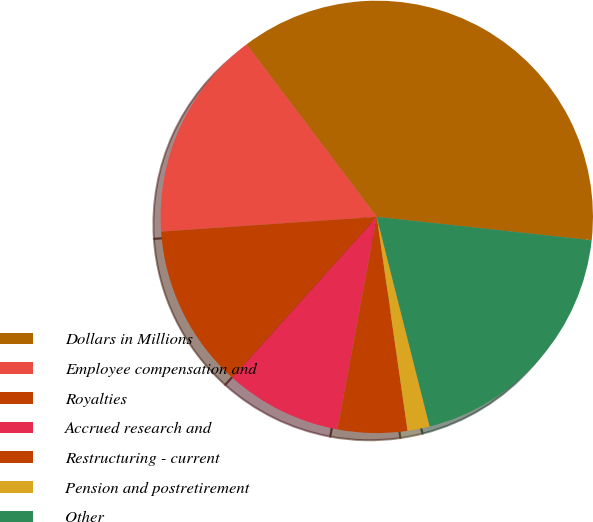<chart> <loc_0><loc_0><loc_500><loc_500><pie_chart><fcel>Dollars in Millions<fcel>Employee compensation and<fcel>Royalties<fcel>Accrued research and<fcel>Restructuring - current<fcel>Pension and postretirement<fcel>Other<nl><fcel>37.01%<fcel>15.8%<fcel>12.27%<fcel>8.73%<fcel>5.19%<fcel>1.66%<fcel>19.34%<nl></chart> 